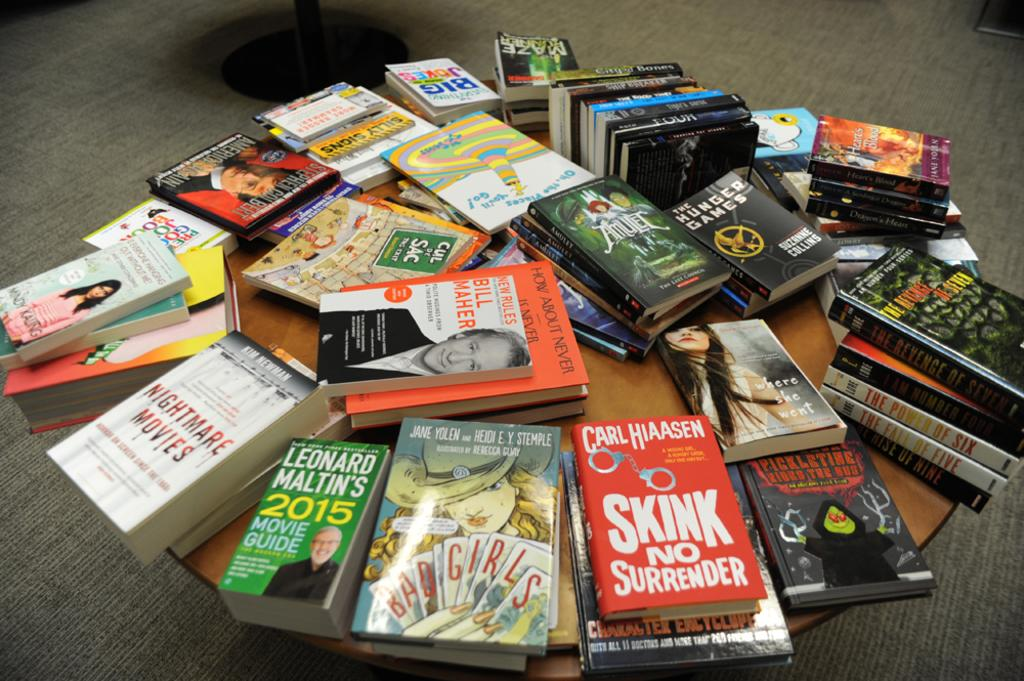<image>
Render a clear and concise summary of the photo. Green book titled Leonard Maltin's 2015 Movie Guide on a table with some other books. 